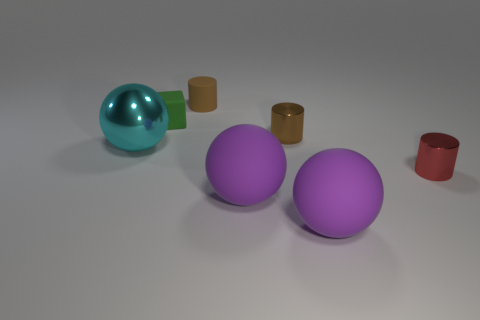What is the size of the shiny cylinder that is the same color as the rubber cylinder?
Give a very brief answer. Small. Is the number of rubber objects behind the small green matte cube the same as the number of balls on the left side of the big cyan thing?
Give a very brief answer. No. What number of objects are either green rubber blocks or cyan metal things?
Make the answer very short. 2. There is a matte block that is the same size as the red shiny cylinder; what color is it?
Ensure brevity in your answer.  Green. How many objects are either objects behind the tiny red cylinder or tiny things that are in front of the cyan thing?
Offer a very short reply. 5. Are there the same number of cyan things left of the big metal object and large cyan metal spheres?
Keep it short and to the point. No. There is a metallic thing behind the cyan metal ball; is it the same size as the shiny thing in front of the big metal ball?
Offer a terse response. Yes. What number of other things are there of the same size as the brown matte cylinder?
Offer a very short reply. 3. There is a purple rubber sphere that is in front of the purple rubber sphere left of the brown metal cylinder; are there any small green objects that are in front of it?
Give a very brief answer. No. Are there any other things that have the same color as the large metallic object?
Give a very brief answer. No. 